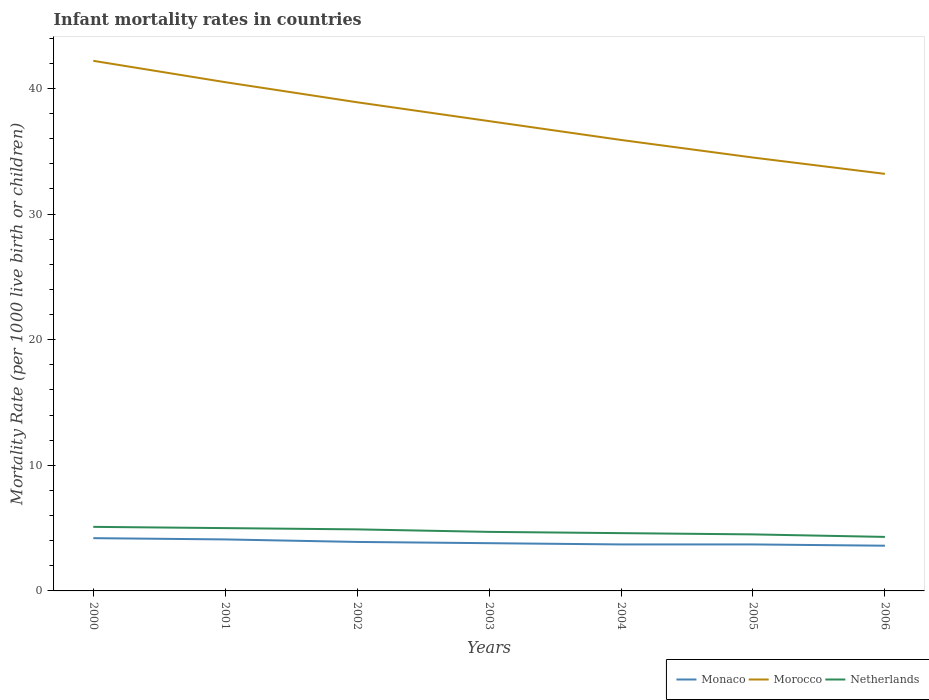In which year was the infant mortality rate in Monaco maximum?
Make the answer very short. 2006. What is the total infant mortality rate in Morocco in the graph?
Your answer should be compact. 1.6. What is the difference between the highest and the second highest infant mortality rate in Morocco?
Your response must be concise. 9. Does the graph contain any zero values?
Your answer should be very brief. No. How many legend labels are there?
Provide a short and direct response. 3. What is the title of the graph?
Your answer should be very brief. Infant mortality rates in countries. What is the label or title of the X-axis?
Provide a short and direct response. Years. What is the label or title of the Y-axis?
Your answer should be compact. Mortality Rate (per 1000 live birth or children). What is the Mortality Rate (per 1000 live birth or children) of Morocco in 2000?
Your answer should be compact. 42.2. What is the Mortality Rate (per 1000 live birth or children) in Monaco in 2001?
Make the answer very short. 4.1. What is the Mortality Rate (per 1000 live birth or children) in Morocco in 2001?
Provide a short and direct response. 40.5. What is the Mortality Rate (per 1000 live birth or children) in Netherlands in 2001?
Provide a succinct answer. 5. What is the Mortality Rate (per 1000 live birth or children) in Monaco in 2002?
Your response must be concise. 3.9. What is the Mortality Rate (per 1000 live birth or children) in Morocco in 2002?
Your answer should be compact. 38.9. What is the Mortality Rate (per 1000 live birth or children) of Netherlands in 2002?
Your response must be concise. 4.9. What is the Mortality Rate (per 1000 live birth or children) in Monaco in 2003?
Give a very brief answer. 3.8. What is the Mortality Rate (per 1000 live birth or children) in Morocco in 2003?
Provide a short and direct response. 37.4. What is the Mortality Rate (per 1000 live birth or children) of Netherlands in 2003?
Make the answer very short. 4.7. What is the Mortality Rate (per 1000 live birth or children) of Monaco in 2004?
Provide a short and direct response. 3.7. What is the Mortality Rate (per 1000 live birth or children) of Morocco in 2004?
Make the answer very short. 35.9. What is the Mortality Rate (per 1000 live birth or children) of Morocco in 2005?
Offer a terse response. 34.5. What is the Mortality Rate (per 1000 live birth or children) in Morocco in 2006?
Offer a very short reply. 33.2. What is the Mortality Rate (per 1000 live birth or children) of Netherlands in 2006?
Keep it short and to the point. 4.3. Across all years, what is the maximum Mortality Rate (per 1000 live birth or children) of Morocco?
Ensure brevity in your answer.  42.2. Across all years, what is the maximum Mortality Rate (per 1000 live birth or children) of Netherlands?
Give a very brief answer. 5.1. Across all years, what is the minimum Mortality Rate (per 1000 live birth or children) of Monaco?
Ensure brevity in your answer.  3.6. Across all years, what is the minimum Mortality Rate (per 1000 live birth or children) in Morocco?
Your answer should be very brief. 33.2. What is the total Mortality Rate (per 1000 live birth or children) of Morocco in the graph?
Ensure brevity in your answer.  262.6. What is the total Mortality Rate (per 1000 live birth or children) in Netherlands in the graph?
Your answer should be compact. 33.1. What is the difference between the Mortality Rate (per 1000 live birth or children) of Monaco in 2000 and that in 2001?
Keep it short and to the point. 0.1. What is the difference between the Mortality Rate (per 1000 live birth or children) in Morocco in 2000 and that in 2001?
Your answer should be very brief. 1.7. What is the difference between the Mortality Rate (per 1000 live birth or children) of Monaco in 2000 and that in 2002?
Ensure brevity in your answer.  0.3. What is the difference between the Mortality Rate (per 1000 live birth or children) of Morocco in 2000 and that in 2002?
Offer a very short reply. 3.3. What is the difference between the Mortality Rate (per 1000 live birth or children) of Netherlands in 2000 and that in 2002?
Offer a very short reply. 0.2. What is the difference between the Mortality Rate (per 1000 live birth or children) of Monaco in 2000 and that in 2003?
Your answer should be compact. 0.4. What is the difference between the Mortality Rate (per 1000 live birth or children) in Morocco in 2000 and that in 2003?
Your answer should be compact. 4.8. What is the difference between the Mortality Rate (per 1000 live birth or children) in Netherlands in 2000 and that in 2004?
Offer a very short reply. 0.5. What is the difference between the Mortality Rate (per 1000 live birth or children) of Monaco in 2000 and that in 2005?
Provide a succinct answer. 0.5. What is the difference between the Mortality Rate (per 1000 live birth or children) of Morocco in 2000 and that in 2005?
Give a very brief answer. 7.7. What is the difference between the Mortality Rate (per 1000 live birth or children) of Netherlands in 2000 and that in 2005?
Provide a short and direct response. 0.6. What is the difference between the Mortality Rate (per 1000 live birth or children) of Morocco in 2000 and that in 2006?
Offer a terse response. 9. What is the difference between the Mortality Rate (per 1000 live birth or children) of Netherlands in 2000 and that in 2006?
Your answer should be very brief. 0.8. What is the difference between the Mortality Rate (per 1000 live birth or children) of Monaco in 2001 and that in 2003?
Give a very brief answer. 0.3. What is the difference between the Mortality Rate (per 1000 live birth or children) in Netherlands in 2001 and that in 2003?
Your answer should be very brief. 0.3. What is the difference between the Mortality Rate (per 1000 live birth or children) of Morocco in 2001 and that in 2004?
Your answer should be very brief. 4.6. What is the difference between the Mortality Rate (per 1000 live birth or children) of Morocco in 2001 and that in 2005?
Make the answer very short. 6. What is the difference between the Mortality Rate (per 1000 live birth or children) of Morocco in 2001 and that in 2006?
Your response must be concise. 7.3. What is the difference between the Mortality Rate (per 1000 live birth or children) of Morocco in 2002 and that in 2003?
Your response must be concise. 1.5. What is the difference between the Mortality Rate (per 1000 live birth or children) of Netherlands in 2002 and that in 2003?
Make the answer very short. 0.2. What is the difference between the Mortality Rate (per 1000 live birth or children) of Morocco in 2002 and that in 2004?
Offer a very short reply. 3. What is the difference between the Mortality Rate (per 1000 live birth or children) in Netherlands in 2002 and that in 2004?
Make the answer very short. 0.3. What is the difference between the Mortality Rate (per 1000 live birth or children) in Monaco in 2002 and that in 2005?
Give a very brief answer. 0.2. What is the difference between the Mortality Rate (per 1000 live birth or children) in Morocco in 2002 and that in 2005?
Provide a short and direct response. 4.4. What is the difference between the Mortality Rate (per 1000 live birth or children) in Netherlands in 2002 and that in 2005?
Make the answer very short. 0.4. What is the difference between the Mortality Rate (per 1000 live birth or children) in Netherlands in 2003 and that in 2004?
Offer a very short reply. 0.1. What is the difference between the Mortality Rate (per 1000 live birth or children) in Netherlands in 2003 and that in 2005?
Provide a succinct answer. 0.2. What is the difference between the Mortality Rate (per 1000 live birth or children) of Morocco in 2003 and that in 2006?
Your response must be concise. 4.2. What is the difference between the Mortality Rate (per 1000 live birth or children) of Netherlands in 2003 and that in 2006?
Ensure brevity in your answer.  0.4. What is the difference between the Mortality Rate (per 1000 live birth or children) of Morocco in 2004 and that in 2005?
Your response must be concise. 1.4. What is the difference between the Mortality Rate (per 1000 live birth or children) of Netherlands in 2004 and that in 2005?
Ensure brevity in your answer.  0.1. What is the difference between the Mortality Rate (per 1000 live birth or children) of Monaco in 2004 and that in 2006?
Your answer should be compact. 0.1. What is the difference between the Mortality Rate (per 1000 live birth or children) in Morocco in 2005 and that in 2006?
Make the answer very short. 1.3. What is the difference between the Mortality Rate (per 1000 live birth or children) of Monaco in 2000 and the Mortality Rate (per 1000 live birth or children) of Morocco in 2001?
Your answer should be very brief. -36.3. What is the difference between the Mortality Rate (per 1000 live birth or children) in Morocco in 2000 and the Mortality Rate (per 1000 live birth or children) in Netherlands in 2001?
Your answer should be very brief. 37.2. What is the difference between the Mortality Rate (per 1000 live birth or children) in Monaco in 2000 and the Mortality Rate (per 1000 live birth or children) in Morocco in 2002?
Provide a short and direct response. -34.7. What is the difference between the Mortality Rate (per 1000 live birth or children) in Morocco in 2000 and the Mortality Rate (per 1000 live birth or children) in Netherlands in 2002?
Provide a short and direct response. 37.3. What is the difference between the Mortality Rate (per 1000 live birth or children) of Monaco in 2000 and the Mortality Rate (per 1000 live birth or children) of Morocco in 2003?
Ensure brevity in your answer.  -33.2. What is the difference between the Mortality Rate (per 1000 live birth or children) of Monaco in 2000 and the Mortality Rate (per 1000 live birth or children) of Netherlands in 2003?
Your answer should be compact. -0.5. What is the difference between the Mortality Rate (per 1000 live birth or children) in Morocco in 2000 and the Mortality Rate (per 1000 live birth or children) in Netherlands in 2003?
Your answer should be compact. 37.5. What is the difference between the Mortality Rate (per 1000 live birth or children) in Monaco in 2000 and the Mortality Rate (per 1000 live birth or children) in Morocco in 2004?
Provide a short and direct response. -31.7. What is the difference between the Mortality Rate (per 1000 live birth or children) in Morocco in 2000 and the Mortality Rate (per 1000 live birth or children) in Netherlands in 2004?
Your answer should be compact. 37.6. What is the difference between the Mortality Rate (per 1000 live birth or children) in Monaco in 2000 and the Mortality Rate (per 1000 live birth or children) in Morocco in 2005?
Keep it short and to the point. -30.3. What is the difference between the Mortality Rate (per 1000 live birth or children) of Monaco in 2000 and the Mortality Rate (per 1000 live birth or children) of Netherlands in 2005?
Offer a terse response. -0.3. What is the difference between the Mortality Rate (per 1000 live birth or children) in Morocco in 2000 and the Mortality Rate (per 1000 live birth or children) in Netherlands in 2005?
Offer a terse response. 37.7. What is the difference between the Mortality Rate (per 1000 live birth or children) in Monaco in 2000 and the Mortality Rate (per 1000 live birth or children) in Netherlands in 2006?
Make the answer very short. -0.1. What is the difference between the Mortality Rate (per 1000 live birth or children) of Morocco in 2000 and the Mortality Rate (per 1000 live birth or children) of Netherlands in 2006?
Give a very brief answer. 37.9. What is the difference between the Mortality Rate (per 1000 live birth or children) of Monaco in 2001 and the Mortality Rate (per 1000 live birth or children) of Morocco in 2002?
Your answer should be compact. -34.8. What is the difference between the Mortality Rate (per 1000 live birth or children) in Morocco in 2001 and the Mortality Rate (per 1000 live birth or children) in Netherlands in 2002?
Keep it short and to the point. 35.6. What is the difference between the Mortality Rate (per 1000 live birth or children) in Monaco in 2001 and the Mortality Rate (per 1000 live birth or children) in Morocco in 2003?
Your answer should be very brief. -33.3. What is the difference between the Mortality Rate (per 1000 live birth or children) in Monaco in 2001 and the Mortality Rate (per 1000 live birth or children) in Netherlands in 2003?
Provide a short and direct response. -0.6. What is the difference between the Mortality Rate (per 1000 live birth or children) of Morocco in 2001 and the Mortality Rate (per 1000 live birth or children) of Netherlands in 2003?
Ensure brevity in your answer.  35.8. What is the difference between the Mortality Rate (per 1000 live birth or children) of Monaco in 2001 and the Mortality Rate (per 1000 live birth or children) of Morocco in 2004?
Give a very brief answer. -31.8. What is the difference between the Mortality Rate (per 1000 live birth or children) of Monaco in 2001 and the Mortality Rate (per 1000 live birth or children) of Netherlands in 2004?
Make the answer very short. -0.5. What is the difference between the Mortality Rate (per 1000 live birth or children) of Morocco in 2001 and the Mortality Rate (per 1000 live birth or children) of Netherlands in 2004?
Your answer should be compact. 35.9. What is the difference between the Mortality Rate (per 1000 live birth or children) of Monaco in 2001 and the Mortality Rate (per 1000 live birth or children) of Morocco in 2005?
Give a very brief answer. -30.4. What is the difference between the Mortality Rate (per 1000 live birth or children) of Monaco in 2001 and the Mortality Rate (per 1000 live birth or children) of Netherlands in 2005?
Your answer should be very brief. -0.4. What is the difference between the Mortality Rate (per 1000 live birth or children) in Morocco in 2001 and the Mortality Rate (per 1000 live birth or children) in Netherlands in 2005?
Your response must be concise. 36. What is the difference between the Mortality Rate (per 1000 live birth or children) in Monaco in 2001 and the Mortality Rate (per 1000 live birth or children) in Morocco in 2006?
Make the answer very short. -29.1. What is the difference between the Mortality Rate (per 1000 live birth or children) of Monaco in 2001 and the Mortality Rate (per 1000 live birth or children) of Netherlands in 2006?
Your answer should be very brief. -0.2. What is the difference between the Mortality Rate (per 1000 live birth or children) in Morocco in 2001 and the Mortality Rate (per 1000 live birth or children) in Netherlands in 2006?
Provide a succinct answer. 36.2. What is the difference between the Mortality Rate (per 1000 live birth or children) of Monaco in 2002 and the Mortality Rate (per 1000 live birth or children) of Morocco in 2003?
Provide a succinct answer. -33.5. What is the difference between the Mortality Rate (per 1000 live birth or children) of Morocco in 2002 and the Mortality Rate (per 1000 live birth or children) of Netherlands in 2003?
Provide a short and direct response. 34.2. What is the difference between the Mortality Rate (per 1000 live birth or children) of Monaco in 2002 and the Mortality Rate (per 1000 live birth or children) of Morocco in 2004?
Keep it short and to the point. -32. What is the difference between the Mortality Rate (per 1000 live birth or children) in Monaco in 2002 and the Mortality Rate (per 1000 live birth or children) in Netherlands in 2004?
Your answer should be compact. -0.7. What is the difference between the Mortality Rate (per 1000 live birth or children) in Morocco in 2002 and the Mortality Rate (per 1000 live birth or children) in Netherlands in 2004?
Offer a very short reply. 34.3. What is the difference between the Mortality Rate (per 1000 live birth or children) in Monaco in 2002 and the Mortality Rate (per 1000 live birth or children) in Morocco in 2005?
Offer a very short reply. -30.6. What is the difference between the Mortality Rate (per 1000 live birth or children) of Monaco in 2002 and the Mortality Rate (per 1000 live birth or children) of Netherlands in 2005?
Your answer should be compact. -0.6. What is the difference between the Mortality Rate (per 1000 live birth or children) of Morocco in 2002 and the Mortality Rate (per 1000 live birth or children) of Netherlands in 2005?
Your answer should be compact. 34.4. What is the difference between the Mortality Rate (per 1000 live birth or children) of Monaco in 2002 and the Mortality Rate (per 1000 live birth or children) of Morocco in 2006?
Your response must be concise. -29.3. What is the difference between the Mortality Rate (per 1000 live birth or children) of Monaco in 2002 and the Mortality Rate (per 1000 live birth or children) of Netherlands in 2006?
Offer a terse response. -0.4. What is the difference between the Mortality Rate (per 1000 live birth or children) in Morocco in 2002 and the Mortality Rate (per 1000 live birth or children) in Netherlands in 2006?
Offer a very short reply. 34.6. What is the difference between the Mortality Rate (per 1000 live birth or children) of Monaco in 2003 and the Mortality Rate (per 1000 live birth or children) of Morocco in 2004?
Provide a succinct answer. -32.1. What is the difference between the Mortality Rate (per 1000 live birth or children) in Morocco in 2003 and the Mortality Rate (per 1000 live birth or children) in Netherlands in 2004?
Give a very brief answer. 32.8. What is the difference between the Mortality Rate (per 1000 live birth or children) in Monaco in 2003 and the Mortality Rate (per 1000 live birth or children) in Morocco in 2005?
Your answer should be very brief. -30.7. What is the difference between the Mortality Rate (per 1000 live birth or children) of Monaco in 2003 and the Mortality Rate (per 1000 live birth or children) of Netherlands in 2005?
Your answer should be compact. -0.7. What is the difference between the Mortality Rate (per 1000 live birth or children) of Morocco in 2003 and the Mortality Rate (per 1000 live birth or children) of Netherlands in 2005?
Keep it short and to the point. 32.9. What is the difference between the Mortality Rate (per 1000 live birth or children) of Monaco in 2003 and the Mortality Rate (per 1000 live birth or children) of Morocco in 2006?
Keep it short and to the point. -29.4. What is the difference between the Mortality Rate (per 1000 live birth or children) in Morocco in 2003 and the Mortality Rate (per 1000 live birth or children) in Netherlands in 2006?
Your answer should be very brief. 33.1. What is the difference between the Mortality Rate (per 1000 live birth or children) in Monaco in 2004 and the Mortality Rate (per 1000 live birth or children) in Morocco in 2005?
Keep it short and to the point. -30.8. What is the difference between the Mortality Rate (per 1000 live birth or children) of Monaco in 2004 and the Mortality Rate (per 1000 live birth or children) of Netherlands in 2005?
Provide a succinct answer. -0.8. What is the difference between the Mortality Rate (per 1000 live birth or children) of Morocco in 2004 and the Mortality Rate (per 1000 live birth or children) of Netherlands in 2005?
Make the answer very short. 31.4. What is the difference between the Mortality Rate (per 1000 live birth or children) of Monaco in 2004 and the Mortality Rate (per 1000 live birth or children) of Morocco in 2006?
Your answer should be compact. -29.5. What is the difference between the Mortality Rate (per 1000 live birth or children) of Monaco in 2004 and the Mortality Rate (per 1000 live birth or children) of Netherlands in 2006?
Ensure brevity in your answer.  -0.6. What is the difference between the Mortality Rate (per 1000 live birth or children) in Morocco in 2004 and the Mortality Rate (per 1000 live birth or children) in Netherlands in 2006?
Provide a succinct answer. 31.6. What is the difference between the Mortality Rate (per 1000 live birth or children) in Monaco in 2005 and the Mortality Rate (per 1000 live birth or children) in Morocco in 2006?
Offer a terse response. -29.5. What is the difference between the Mortality Rate (per 1000 live birth or children) of Monaco in 2005 and the Mortality Rate (per 1000 live birth or children) of Netherlands in 2006?
Make the answer very short. -0.6. What is the difference between the Mortality Rate (per 1000 live birth or children) of Morocco in 2005 and the Mortality Rate (per 1000 live birth or children) of Netherlands in 2006?
Your answer should be very brief. 30.2. What is the average Mortality Rate (per 1000 live birth or children) in Monaco per year?
Provide a short and direct response. 3.86. What is the average Mortality Rate (per 1000 live birth or children) of Morocco per year?
Your answer should be compact. 37.51. What is the average Mortality Rate (per 1000 live birth or children) of Netherlands per year?
Offer a very short reply. 4.73. In the year 2000, what is the difference between the Mortality Rate (per 1000 live birth or children) of Monaco and Mortality Rate (per 1000 live birth or children) of Morocco?
Offer a very short reply. -38. In the year 2000, what is the difference between the Mortality Rate (per 1000 live birth or children) in Monaco and Mortality Rate (per 1000 live birth or children) in Netherlands?
Keep it short and to the point. -0.9. In the year 2000, what is the difference between the Mortality Rate (per 1000 live birth or children) of Morocco and Mortality Rate (per 1000 live birth or children) of Netherlands?
Your response must be concise. 37.1. In the year 2001, what is the difference between the Mortality Rate (per 1000 live birth or children) of Monaco and Mortality Rate (per 1000 live birth or children) of Morocco?
Provide a short and direct response. -36.4. In the year 2001, what is the difference between the Mortality Rate (per 1000 live birth or children) in Monaco and Mortality Rate (per 1000 live birth or children) in Netherlands?
Your answer should be very brief. -0.9. In the year 2001, what is the difference between the Mortality Rate (per 1000 live birth or children) of Morocco and Mortality Rate (per 1000 live birth or children) of Netherlands?
Your answer should be compact. 35.5. In the year 2002, what is the difference between the Mortality Rate (per 1000 live birth or children) of Monaco and Mortality Rate (per 1000 live birth or children) of Morocco?
Your answer should be compact. -35. In the year 2002, what is the difference between the Mortality Rate (per 1000 live birth or children) in Morocco and Mortality Rate (per 1000 live birth or children) in Netherlands?
Your response must be concise. 34. In the year 2003, what is the difference between the Mortality Rate (per 1000 live birth or children) of Monaco and Mortality Rate (per 1000 live birth or children) of Morocco?
Make the answer very short. -33.6. In the year 2003, what is the difference between the Mortality Rate (per 1000 live birth or children) of Morocco and Mortality Rate (per 1000 live birth or children) of Netherlands?
Your response must be concise. 32.7. In the year 2004, what is the difference between the Mortality Rate (per 1000 live birth or children) of Monaco and Mortality Rate (per 1000 live birth or children) of Morocco?
Ensure brevity in your answer.  -32.2. In the year 2004, what is the difference between the Mortality Rate (per 1000 live birth or children) of Morocco and Mortality Rate (per 1000 live birth or children) of Netherlands?
Make the answer very short. 31.3. In the year 2005, what is the difference between the Mortality Rate (per 1000 live birth or children) of Monaco and Mortality Rate (per 1000 live birth or children) of Morocco?
Offer a very short reply. -30.8. In the year 2005, what is the difference between the Mortality Rate (per 1000 live birth or children) in Monaco and Mortality Rate (per 1000 live birth or children) in Netherlands?
Provide a succinct answer. -0.8. In the year 2005, what is the difference between the Mortality Rate (per 1000 live birth or children) in Morocco and Mortality Rate (per 1000 live birth or children) in Netherlands?
Your response must be concise. 30. In the year 2006, what is the difference between the Mortality Rate (per 1000 live birth or children) of Monaco and Mortality Rate (per 1000 live birth or children) of Morocco?
Offer a very short reply. -29.6. In the year 2006, what is the difference between the Mortality Rate (per 1000 live birth or children) in Monaco and Mortality Rate (per 1000 live birth or children) in Netherlands?
Offer a very short reply. -0.7. In the year 2006, what is the difference between the Mortality Rate (per 1000 live birth or children) in Morocco and Mortality Rate (per 1000 live birth or children) in Netherlands?
Your answer should be very brief. 28.9. What is the ratio of the Mortality Rate (per 1000 live birth or children) of Monaco in 2000 to that in 2001?
Ensure brevity in your answer.  1.02. What is the ratio of the Mortality Rate (per 1000 live birth or children) of Morocco in 2000 to that in 2001?
Keep it short and to the point. 1.04. What is the ratio of the Mortality Rate (per 1000 live birth or children) of Netherlands in 2000 to that in 2001?
Offer a very short reply. 1.02. What is the ratio of the Mortality Rate (per 1000 live birth or children) of Morocco in 2000 to that in 2002?
Ensure brevity in your answer.  1.08. What is the ratio of the Mortality Rate (per 1000 live birth or children) in Netherlands in 2000 to that in 2002?
Provide a short and direct response. 1.04. What is the ratio of the Mortality Rate (per 1000 live birth or children) in Monaco in 2000 to that in 2003?
Ensure brevity in your answer.  1.11. What is the ratio of the Mortality Rate (per 1000 live birth or children) in Morocco in 2000 to that in 2003?
Offer a very short reply. 1.13. What is the ratio of the Mortality Rate (per 1000 live birth or children) in Netherlands in 2000 to that in 2003?
Your response must be concise. 1.09. What is the ratio of the Mortality Rate (per 1000 live birth or children) in Monaco in 2000 to that in 2004?
Offer a terse response. 1.14. What is the ratio of the Mortality Rate (per 1000 live birth or children) of Morocco in 2000 to that in 2004?
Make the answer very short. 1.18. What is the ratio of the Mortality Rate (per 1000 live birth or children) of Netherlands in 2000 to that in 2004?
Provide a short and direct response. 1.11. What is the ratio of the Mortality Rate (per 1000 live birth or children) of Monaco in 2000 to that in 2005?
Give a very brief answer. 1.14. What is the ratio of the Mortality Rate (per 1000 live birth or children) in Morocco in 2000 to that in 2005?
Ensure brevity in your answer.  1.22. What is the ratio of the Mortality Rate (per 1000 live birth or children) of Netherlands in 2000 to that in 2005?
Provide a short and direct response. 1.13. What is the ratio of the Mortality Rate (per 1000 live birth or children) of Morocco in 2000 to that in 2006?
Your response must be concise. 1.27. What is the ratio of the Mortality Rate (per 1000 live birth or children) of Netherlands in 2000 to that in 2006?
Your response must be concise. 1.19. What is the ratio of the Mortality Rate (per 1000 live birth or children) in Monaco in 2001 to that in 2002?
Provide a short and direct response. 1.05. What is the ratio of the Mortality Rate (per 1000 live birth or children) of Morocco in 2001 to that in 2002?
Make the answer very short. 1.04. What is the ratio of the Mortality Rate (per 1000 live birth or children) of Netherlands in 2001 to that in 2002?
Offer a very short reply. 1.02. What is the ratio of the Mortality Rate (per 1000 live birth or children) in Monaco in 2001 to that in 2003?
Ensure brevity in your answer.  1.08. What is the ratio of the Mortality Rate (per 1000 live birth or children) of Morocco in 2001 to that in 2003?
Give a very brief answer. 1.08. What is the ratio of the Mortality Rate (per 1000 live birth or children) in Netherlands in 2001 to that in 2003?
Provide a short and direct response. 1.06. What is the ratio of the Mortality Rate (per 1000 live birth or children) of Monaco in 2001 to that in 2004?
Provide a short and direct response. 1.11. What is the ratio of the Mortality Rate (per 1000 live birth or children) in Morocco in 2001 to that in 2004?
Make the answer very short. 1.13. What is the ratio of the Mortality Rate (per 1000 live birth or children) in Netherlands in 2001 to that in 2004?
Your response must be concise. 1.09. What is the ratio of the Mortality Rate (per 1000 live birth or children) of Monaco in 2001 to that in 2005?
Keep it short and to the point. 1.11. What is the ratio of the Mortality Rate (per 1000 live birth or children) in Morocco in 2001 to that in 2005?
Keep it short and to the point. 1.17. What is the ratio of the Mortality Rate (per 1000 live birth or children) of Monaco in 2001 to that in 2006?
Offer a very short reply. 1.14. What is the ratio of the Mortality Rate (per 1000 live birth or children) of Morocco in 2001 to that in 2006?
Offer a very short reply. 1.22. What is the ratio of the Mortality Rate (per 1000 live birth or children) of Netherlands in 2001 to that in 2006?
Your response must be concise. 1.16. What is the ratio of the Mortality Rate (per 1000 live birth or children) of Monaco in 2002 to that in 2003?
Offer a terse response. 1.03. What is the ratio of the Mortality Rate (per 1000 live birth or children) of Morocco in 2002 to that in 2003?
Make the answer very short. 1.04. What is the ratio of the Mortality Rate (per 1000 live birth or children) in Netherlands in 2002 to that in 2003?
Give a very brief answer. 1.04. What is the ratio of the Mortality Rate (per 1000 live birth or children) of Monaco in 2002 to that in 2004?
Offer a very short reply. 1.05. What is the ratio of the Mortality Rate (per 1000 live birth or children) in Morocco in 2002 to that in 2004?
Your answer should be very brief. 1.08. What is the ratio of the Mortality Rate (per 1000 live birth or children) of Netherlands in 2002 to that in 2004?
Provide a succinct answer. 1.07. What is the ratio of the Mortality Rate (per 1000 live birth or children) in Monaco in 2002 to that in 2005?
Make the answer very short. 1.05. What is the ratio of the Mortality Rate (per 1000 live birth or children) in Morocco in 2002 to that in 2005?
Offer a terse response. 1.13. What is the ratio of the Mortality Rate (per 1000 live birth or children) in Netherlands in 2002 to that in 2005?
Your response must be concise. 1.09. What is the ratio of the Mortality Rate (per 1000 live birth or children) in Monaco in 2002 to that in 2006?
Make the answer very short. 1.08. What is the ratio of the Mortality Rate (per 1000 live birth or children) in Morocco in 2002 to that in 2006?
Ensure brevity in your answer.  1.17. What is the ratio of the Mortality Rate (per 1000 live birth or children) of Netherlands in 2002 to that in 2006?
Keep it short and to the point. 1.14. What is the ratio of the Mortality Rate (per 1000 live birth or children) in Morocco in 2003 to that in 2004?
Offer a terse response. 1.04. What is the ratio of the Mortality Rate (per 1000 live birth or children) in Netherlands in 2003 to that in 2004?
Keep it short and to the point. 1.02. What is the ratio of the Mortality Rate (per 1000 live birth or children) of Morocco in 2003 to that in 2005?
Offer a terse response. 1.08. What is the ratio of the Mortality Rate (per 1000 live birth or children) in Netherlands in 2003 to that in 2005?
Provide a short and direct response. 1.04. What is the ratio of the Mortality Rate (per 1000 live birth or children) in Monaco in 2003 to that in 2006?
Provide a succinct answer. 1.06. What is the ratio of the Mortality Rate (per 1000 live birth or children) of Morocco in 2003 to that in 2006?
Give a very brief answer. 1.13. What is the ratio of the Mortality Rate (per 1000 live birth or children) in Netherlands in 2003 to that in 2006?
Provide a succinct answer. 1.09. What is the ratio of the Mortality Rate (per 1000 live birth or children) in Morocco in 2004 to that in 2005?
Offer a terse response. 1.04. What is the ratio of the Mortality Rate (per 1000 live birth or children) in Netherlands in 2004 to that in 2005?
Ensure brevity in your answer.  1.02. What is the ratio of the Mortality Rate (per 1000 live birth or children) in Monaco in 2004 to that in 2006?
Provide a short and direct response. 1.03. What is the ratio of the Mortality Rate (per 1000 live birth or children) in Morocco in 2004 to that in 2006?
Keep it short and to the point. 1.08. What is the ratio of the Mortality Rate (per 1000 live birth or children) in Netherlands in 2004 to that in 2006?
Your response must be concise. 1.07. What is the ratio of the Mortality Rate (per 1000 live birth or children) in Monaco in 2005 to that in 2006?
Provide a succinct answer. 1.03. What is the ratio of the Mortality Rate (per 1000 live birth or children) of Morocco in 2005 to that in 2006?
Your response must be concise. 1.04. What is the ratio of the Mortality Rate (per 1000 live birth or children) in Netherlands in 2005 to that in 2006?
Give a very brief answer. 1.05. What is the difference between the highest and the second highest Mortality Rate (per 1000 live birth or children) of Monaco?
Keep it short and to the point. 0.1. What is the difference between the highest and the lowest Mortality Rate (per 1000 live birth or children) in Monaco?
Provide a short and direct response. 0.6. What is the difference between the highest and the lowest Mortality Rate (per 1000 live birth or children) of Morocco?
Offer a terse response. 9. What is the difference between the highest and the lowest Mortality Rate (per 1000 live birth or children) of Netherlands?
Make the answer very short. 0.8. 